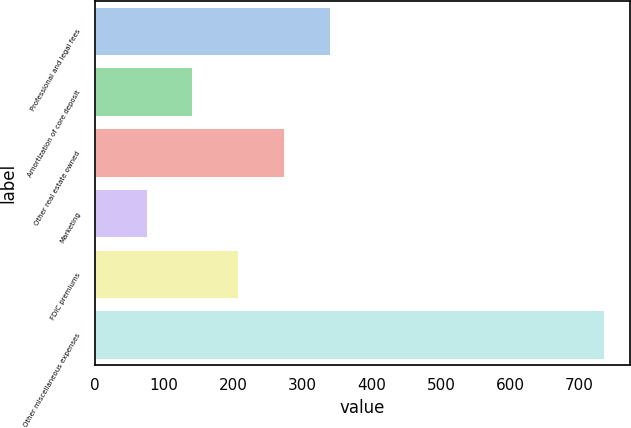<chart> <loc_0><loc_0><loc_500><loc_500><bar_chart><fcel>Professional and legal fees<fcel>Amortization of core deposit<fcel>Other real estate owned<fcel>Marketing<fcel>FDIC premiums<fcel>Other miscellaneous expenses<nl><fcel>339.4<fcel>141.1<fcel>273.3<fcel>75<fcel>207.2<fcel>736<nl></chart> 